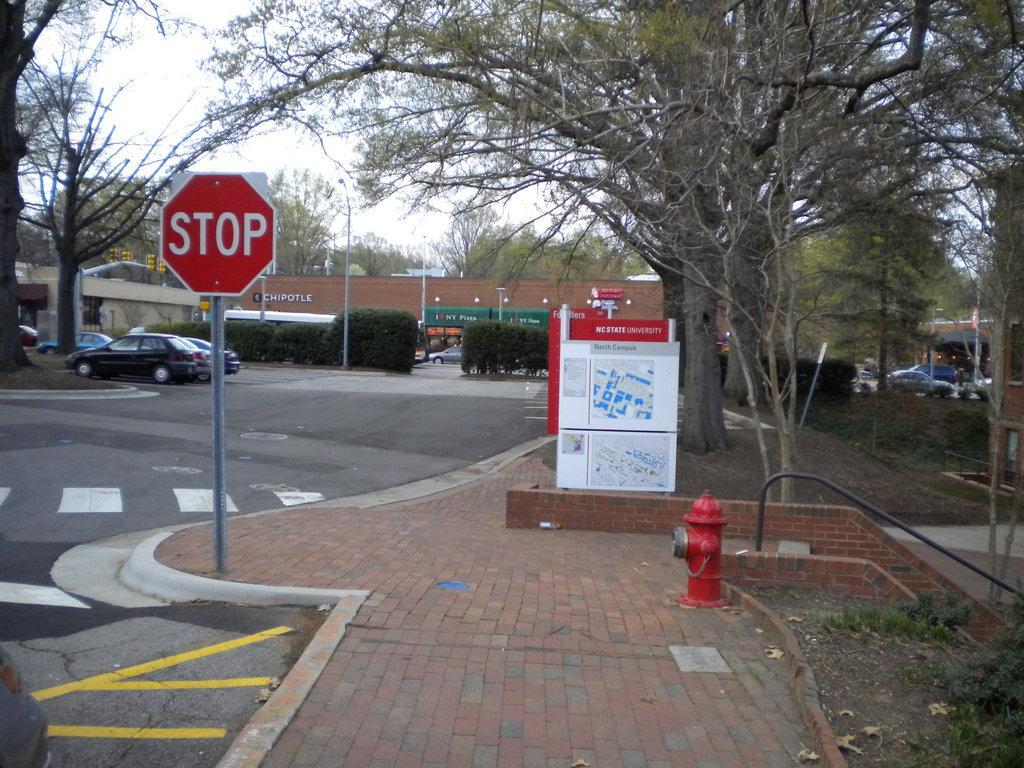Describe this image in one or two sentences. In this image we can see some houses, light poles, signboard, there is a fire hydrant, there are plants, trees, vehicles, there is a board with text and images on it, also we can see the sky. 